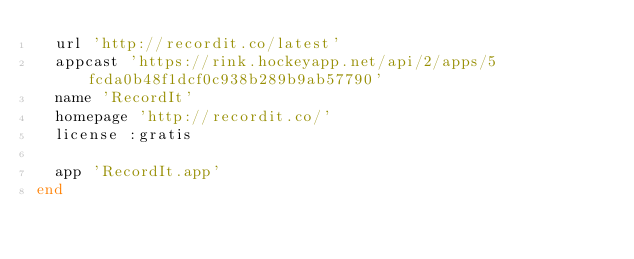Convert code to text. <code><loc_0><loc_0><loc_500><loc_500><_Ruby_>  url 'http://recordit.co/latest'
  appcast 'https://rink.hockeyapp.net/api/2/apps/5fcda0b48f1dcf0c938b289b9ab57790'
  name 'RecordIt'
  homepage 'http://recordit.co/'
  license :gratis

  app 'RecordIt.app'
end
</code> 